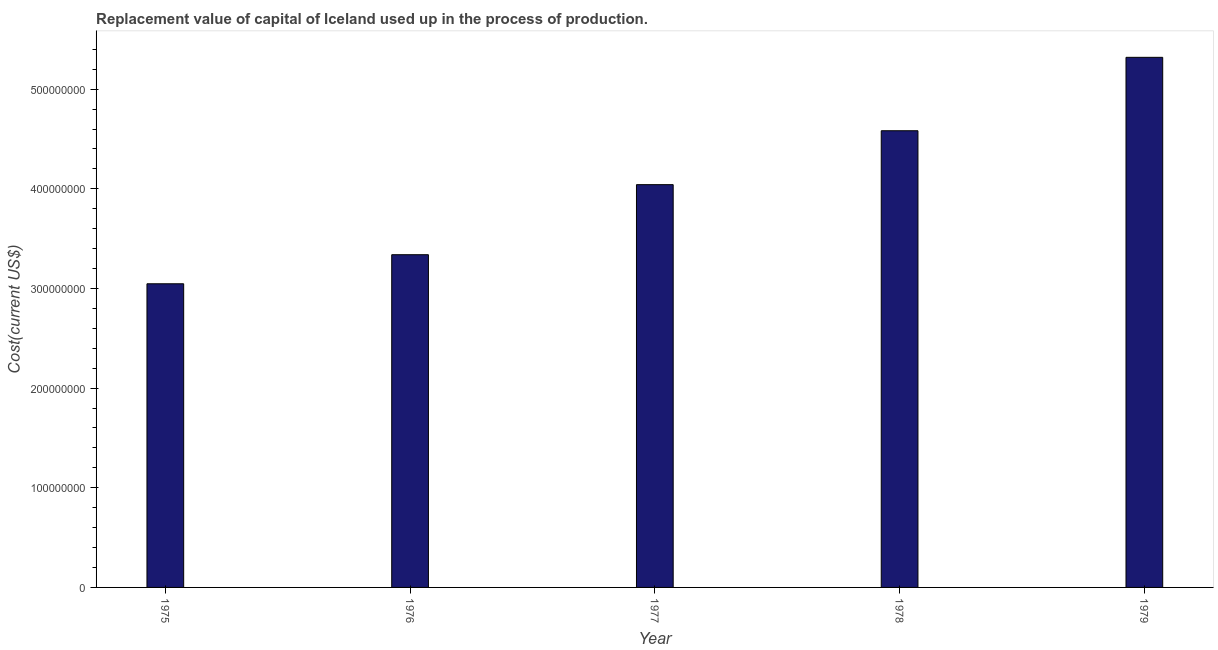Does the graph contain any zero values?
Give a very brief answer. No. What is the title of the graph?
Give a very brief answer. Replacement value of capital of Iceland used up in the process of production. What is the label or title of the Y-axis?
Give a very brief answer. Cost(current US$). What is the consumption of fixed capital in 1975?
Keep it short and to the point. 3.05e+08. Across all years, what is the maximum consumption of fixed capital?
Offer a very short reply. 5.32e+08. Across all years, what is the minimum consumption of fixed capital?
Your response must be concise. 3.05e+08. In which year was the consumption of fixed capital maximum?
Keep it short and to the point. 1979. In which year was the consumption of fixed capital minimum?
Keep it short and to the point. 1975. What is the sum of the consumption of fixed capital?
Your answer should be compact. 2.03e+09. What is the difference between the consumption of fixed capital in 1977 and 1978?
Offer a terse response. -5.41e+07. What is the average consumption of fixed capital per year?
Offer a very short reply. 4.07e+08. What is the median consumption of fixed capital?
Keep it short and to the point. 4.04e+08. In how many years, is the consumption of fixed capital greater than 180000000 US$?
Ensure brevity in your answer.  5. What is the ratio of the consumption of fixed capital in 1977 to that in 1978?
Provide a short and direct response. 0.88. What is the difference between the highest and the second highest consumption of fixed capital?
Give a very brief answer. 7.37e+07. Is the sum of the consumption of fixed capital in 1976 and 1979 greater than the maximum consumption of fixed capital across all years?
Keep it short and to the point. Yes. What is the difference between the highest and the lowest consumption of fixed capital?
Offer a terse response. 2.27e+08. How many years are there in the graph?
Ensure brevity in your answer.  5. Are the values on the major ticks of Y-axis written in scientific E-notation?
Give a very brief answer. No. What is the Cost(current US$) in 1975?
Your answer should be compact. 3.05e+08. What is the Cost(current US$) in 1976?
Make the answer very short. 3.34e+08. What is the Cost(current US$) of 1977?
Provide a short and direct response. 4.04e+08. What is the Cost(current US$) in 1978?
Offer a terse response. 4.58e+08. What is the Cost(current US$) in 1979?
Keep it short and to the point. 5.32e+08. What is the difference between the Cost(current US$) in 1975 and 1976?
Offer a terse response. -2.92e+07. What is the difference between the Cost(current US$) in 1975 and 1977?
Give a very brief answer. -9.95e+07. What is the difference between the Cost(current US$) in 1975 and 1978?
Offer a very short reply. -1.54e+08. What is the difference between the Cost(current US$) in 1975 and 1979?
Your response must be concise. -2.27e+08. What is the difference between the Cost(current US$) in 1976 and 1977?
Provide a succinct answer. -7.03e+07. What is the difference between the Cost(current US$) in 1976 and 1978?
Ensure brevity in your answer.  -1.24e+08. What is the difference between the Cost(current US$) in 1976 and 1979?
Your answer should be very brief. -1.98e+08. What is the difference between the Cost(current US$) in 1977 and 1978?
Provide a short and direct response. -5.41e+07. What is the difference between the Cost(current US$) in 1977 and 1979?
Your answer should be compact. -1.28e+08. What is the difference between the Cost(current US$) in 1978 and 1979?
Offer a terse response. -7.37e+07. What is the ratio of the Cost(current US$) in 1975 to that in 1977?
Your answer should be very brief. 0.75. What is the ratio of the Cost(current US$) in 1975 to that in 1978?
Offer a terse response. 0.67. What is the ratio of the Cost(current US$) in 1975 to that in 1979?
Keep it short and to the point. 0.57. What is the ratio of the Cost(current US$) in 1976 to that in 1977?
Your answer should be very brief. 0.83. What is the ratio of the Cost(current US$) in 1976 to that in 1978?
Keep it short and to the point. 0.73. What is the ratio of the Cost(current US$) in 1976 to that in 1979?
Offer a terse response. 0.63. What is the ratio of the Cost(current US$) in 1977 to that in 1978?
Make the answer very short. 0.88. What is the ratio of the Cost(current US$) in 1977 to that in 1979?
Your response must be concise. 0.76. What is the ratio of the Cost(current US$) in 1978 to that in 1979?
Your response must be concise. 0.86. 